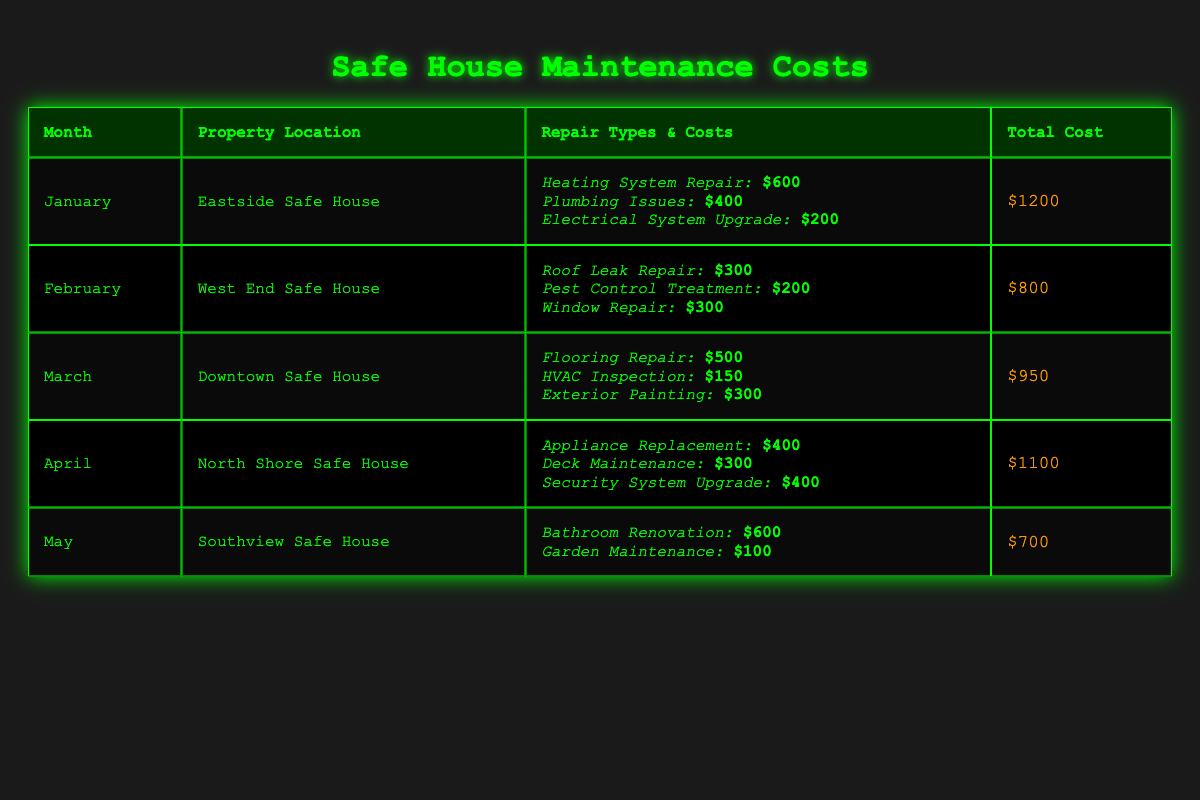What was the total cost for repairs in February? From the table, the total cost listed for February is $800.
Answer: $800 Which property had the highest total maintenance cost in the first quarter of the year? In January, the Eastside Safe House had a total cost of $1200, February's West End Safe House cost $800, and March's Downtown Safe House cost $950. The highest cost among these is $1200 for the Eastside Safe House in January.
Answer: Eastside Safe House How much was spent on plumbing issues in January? In the January row, the cost for plumbing issues is specifically listed as $400.
Answer: $400 What is the total cost for repairs in April and May combined? The total cost in April is $1100 and in May is $700. Adding these together gives $1100 + $700 = $1800.
Answer: $1800 Is it true that the Southview Safe House had more maintenance costs than the Downtown Safe House? The Southview Safe House's total cost in May is $700, while the Downtown Safe House's total cost in March is $950. Therefore, it is false that Southview had more costs than Downtown.
Answer: No Which type of repair incurred the highest cost in April? The highest single cost in April was for the security system upgrade at $400, which matches the cost of the appliance replacement. However, the highest distinct cost is the security system upgrade.
Answer: Security System Upgrade What is the average total cost incurred by the safe houses from January to May? The total costs are $1200, $800, $950, $1100, and $700, which sums up to $3850. There are 5 months, so the average is $3850 / 5 = $770.
Answer: $770 Which month had the lowest monthly maintenance cost? The costs for each month are $1200 for January, $800 for February, $950 for March, $1100 for April, and $700 for May. The lowest cost is in May at $700.
Answer: May What were the combined costs for electrical system upgrades and plumbing issues across the months? The electrical system upgrade in January costs $200 and the plumbing issue costs $400 in January. There are no other electrical upgrades or plumbing listed in the subsequent months, so they combine to $200 + $400 = $600.
Answer: $600 